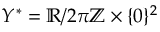Convert formula to latex. <formula><loc_0><loc_0><loc_500><loc_500>Y ^ { * } = \mathbb { R } / 2 \pi \mathbb { Z } \times \{ 0 \} ^ { 2 }</formula> 